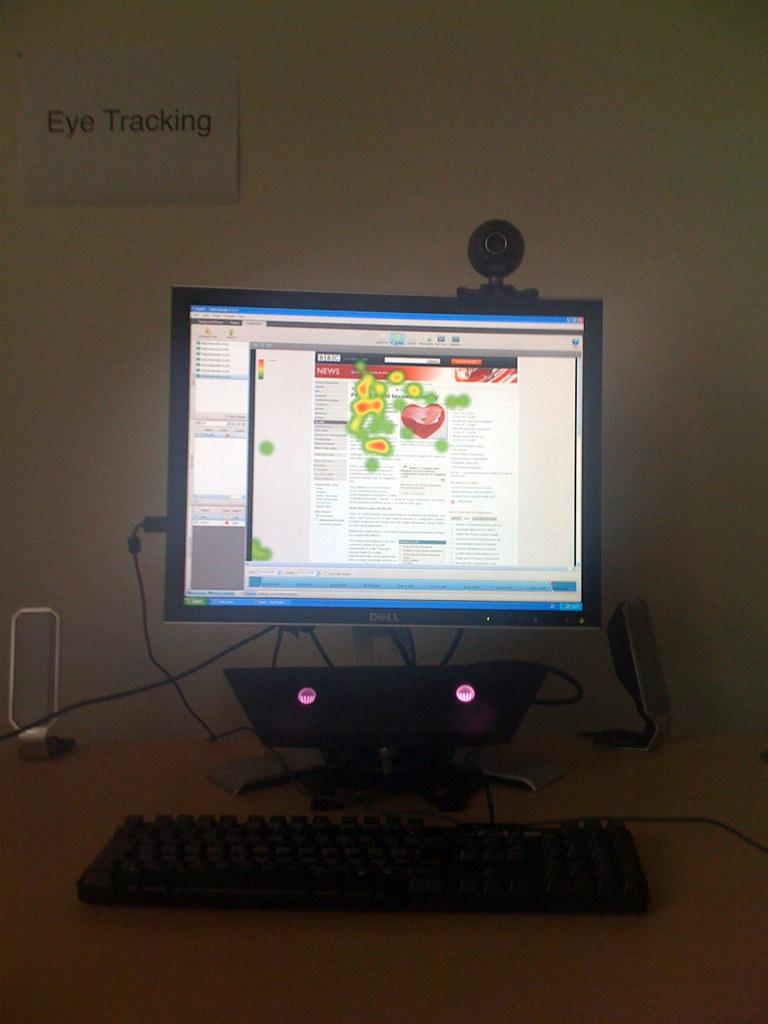<image>
Create a compact narrative representing the image presented. a computer screen with a sign above it that reads 'eye tracking' 